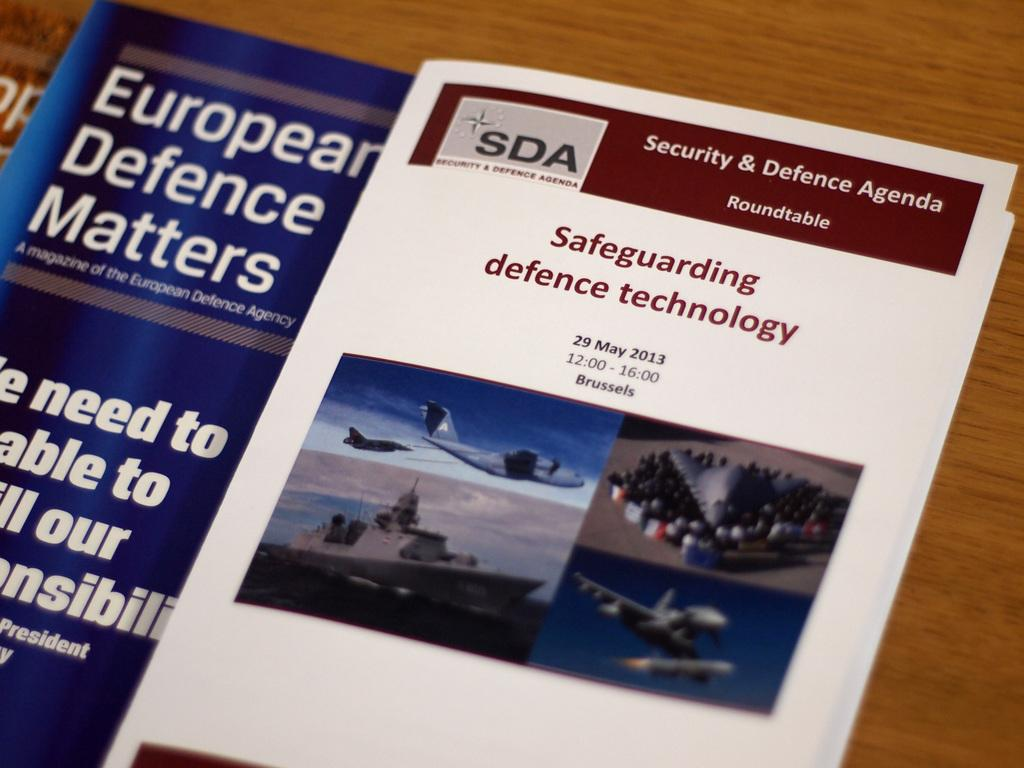<image>
Share a concise interpretation of the image provided. A booklet for the Security and Defence Agenda roundtable is dated 29 May 2013. 